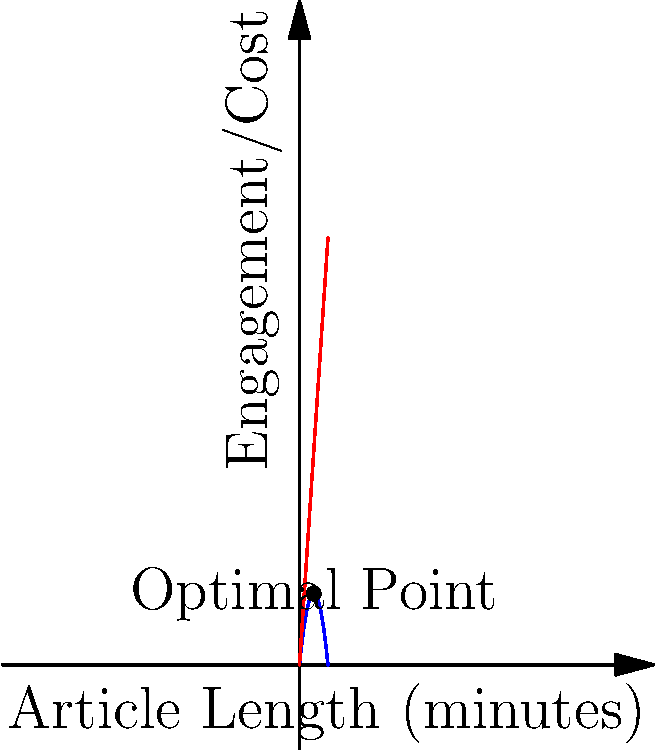As a journalist aiming to maximize audience engagement while considering production costs, you're tasked with optimizing article length. The graph shows the relationship between article length (in minutes of reading time) and audience engagement (blue curve) as well as production cost (red line). The engagement function is given by $E(x) = -0.5x^2 + 10x$, where $x$ is the article length in minutes. The production cost function is $C(x) = 15x$. What is the optimal article length that maximizes the difference between engagement and cost, and what is this maximum difference? To solve this optimization problem, we need to follow these steps:

1) The function we want to maximize is the difference between engagement and cost:
   $f(x) = E(x) - C(x) = (-0.5x^2 + 10x) - 15x = -0.5x^2 - 5x$

2) To find the maximum, we need to find where the derivative of this function equals zero:
   $f'(x) = -x - 5$
   Set this equal to zero: $-x - 5 = 0$
   Solve for x: $x = -5$

3) The second derivative is $f''(x) = -1$, which is always negative, confirming this is a maximum.

4) However, since article length can't be negative, the actual maximum must occur at the boundary of our domain, which is $x = 0$.

5) To find the maximum difference, we evaluate $f(0)$:
   $f(0) = -0.5(0)^2 - 5(0) = 0$

Therefore, the optimal strategy is to not write an article at all, resulting in no engagement but also no cost, for a net difference of 0.

This counterintuitive result highlights the importance of considering more nuanced models in real-world journalism, where factors like minimum viable article length and long-term audience building would likely be important.
Answer: Optimal length: 0 minutes; Maximum difference: 0 